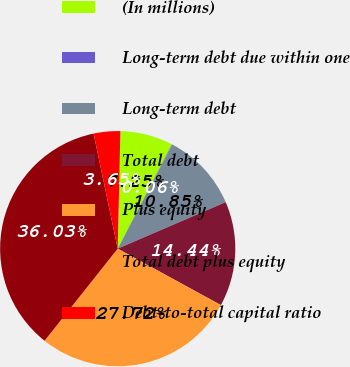<chart> <loc_0><loc_0><loc_500><loc_500><pie_chart><fcel>(In millions)<fcel>Long-term debt due within one<fcel>Long-term debt<fcel>Total debt<fcel>Plus equity<fcel>Total debt plus equity<fcel>Debt-to-total capital ratio<nl><fcel>7.25%<fcel>0.06%<fcel>10.85%<fcel>14.44%<fcel>27.72%<fcel>36.03%<fcel>3.65%<nl></chart> 